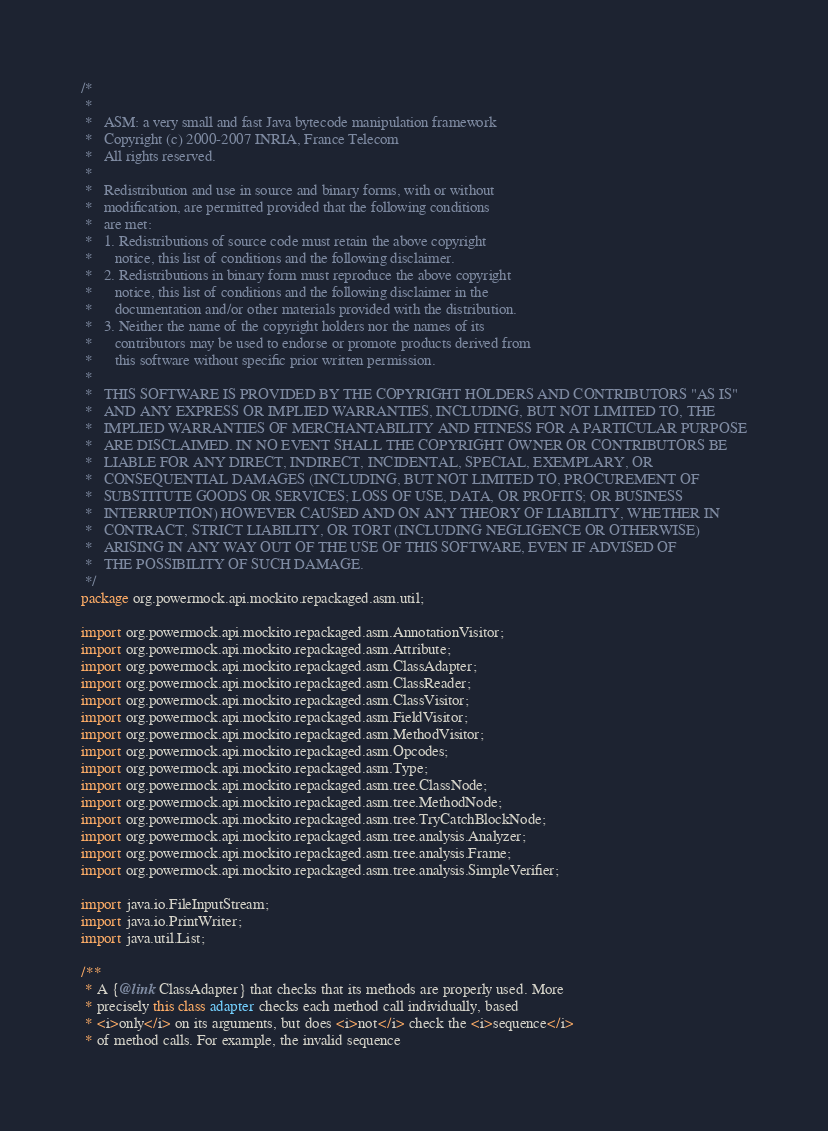<code> <loc_0><loc_0><loc_500><loc_500><_Java_>/*
 *
 *   ASM: a very small and fast Java bytecode manipulation framework
 *   Copyright (c) 2000-2007 INRIA, France Telecom
 *   All rights reserved.
 *
 *   Redistribution and use in source and binary forms, with or without
 *   modification, are permitted provided that the following conditions
 *   are met:
 *   1. Redistributions of source code must retain the above copyright
 *      notice, this list of conditions and the following disclaimer.
 *   2. Redistributions in binary form must reproduce the above copyright
 *      notice, this list of conditions and the following disclaimer in the
 *      documentation and/or other materials provided with the distribution.
 *   3. Neither the name of the copyright holders nor the names of its
 *      contributors may be used to endorse or promote products derived from
 *      this software without specific prior written permission.
 *
 *   THIS SOFTWARE IS PROVIDED BY THE COPYRIGHT HOLDERS AND CONTRIBUTORS "AS IS"
 *   AND ANY EXPRESS OR IMPLIED WARRANTIES, INCLUDING, BUT NOT LIMITED TO, THE
 *   IMPLIED WARRANTIES OF MERCHANTABILITY AND FITNESS FOR A PARTICULAR PURPOSE
 *   ARE DISCLAIMED. IN NO EVENT SHALL THE COPYRIGHT OWNER OR CONTRIBUTORS BE
 *   LIABLE FOR ANY DIRECT, INDIRECT, INCIDENTAL, SPECIAL, EXEMPLARY, OR
 *   CONSEQUENTIAL DAMAGES (INCLUDING, BUT NOT LIMITED TO, PROCUREMENT OF
 *   SUBSTITUTE GOODS OR SERVICES; LOSS OF USE, DATA, OR PROFITS; OR BUSINESS
 *   INTERRUPTION) HOWEVER CAUSED AND ON ANY THEORY OF LIABILITY, WHETHER IN
 *   CONTRACT, STRICT LIABILITY, OR TORT (INCLUDING NEGLIGENCE OR OTHERWISE)
 *   ARISING IN ANY WAY OUT OF THE USE OF THIS SOFTWARE, EVEN IF ADVISED OF
 *   THE POSSIBILITY OF SUCH DAMAGE.
 */
package org.powermock.api.mockito.repackaged.asm.util;

import org.powermock.api.mockito.repackaged.asm.AnnotationVisitor;
import org.powermock.api.mockito.repackaged.asm.Attribute;
import org.powermock.api.mockito.repackaged.asm.ClassAdapter;
import org.powermock.api.mockito.repackaged.asm.ClassReader;
import org.powermock.api.mockito.repackaged.asm.ClassVisitor;
import org.powermock.api.mockito.repackaged.asm.FieldVisitor;
import org.powermock.api.mockito.repackaged.asm.MethodVisitor;
import org.powermock.api.mockito.repackaged.asm.Opcodes;
import org.powermock.api.mockito.repackaged.asm.Type;
import org.powermock.api.mockito.repackaged.asm.tree.ClassNode;
import org.powermock.api.mockito.repackaged.asm.tree.MethodNode;
import org.powermock.api.mockito.repackaged.asm.tree.TryCatchBlockNode;
import org.powermock.api.mockito.repackaged.asm.tree.analysis.Analyzer;
import org.powermock.api.mockito.repackaged.asm.tree.analysis.Frame;
import org.powermock.api.mockito.repackaged.asm.tree.analysis.SimpleVerifier;

import java.io.FileInputStream;
import java.io.PrintWriter;
import java.util.List;

/**
 * A {@link ClassAdapter} that checks that its methods are properly used. More
 * precisely this class adapter checks each method call individually, based
 * <i>only</i> on its arguments, but does <i>not</i> check the <i>sequence</i>
 * of method calls. For example, the invalid sequence</code> 